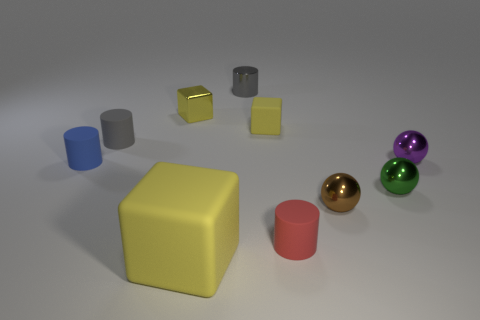What shapes can be seen in this image and how do they contrast with each other? The image showcases a variety of geometric shapes, including a sphere, cylinder, and cubes. They contrast in terms of their geometric properties; some have curved surfaces while others have flat surfaces and sharp angles, creating a diverse set of forms that could be discussing the principles of geometry or 3D object design. 